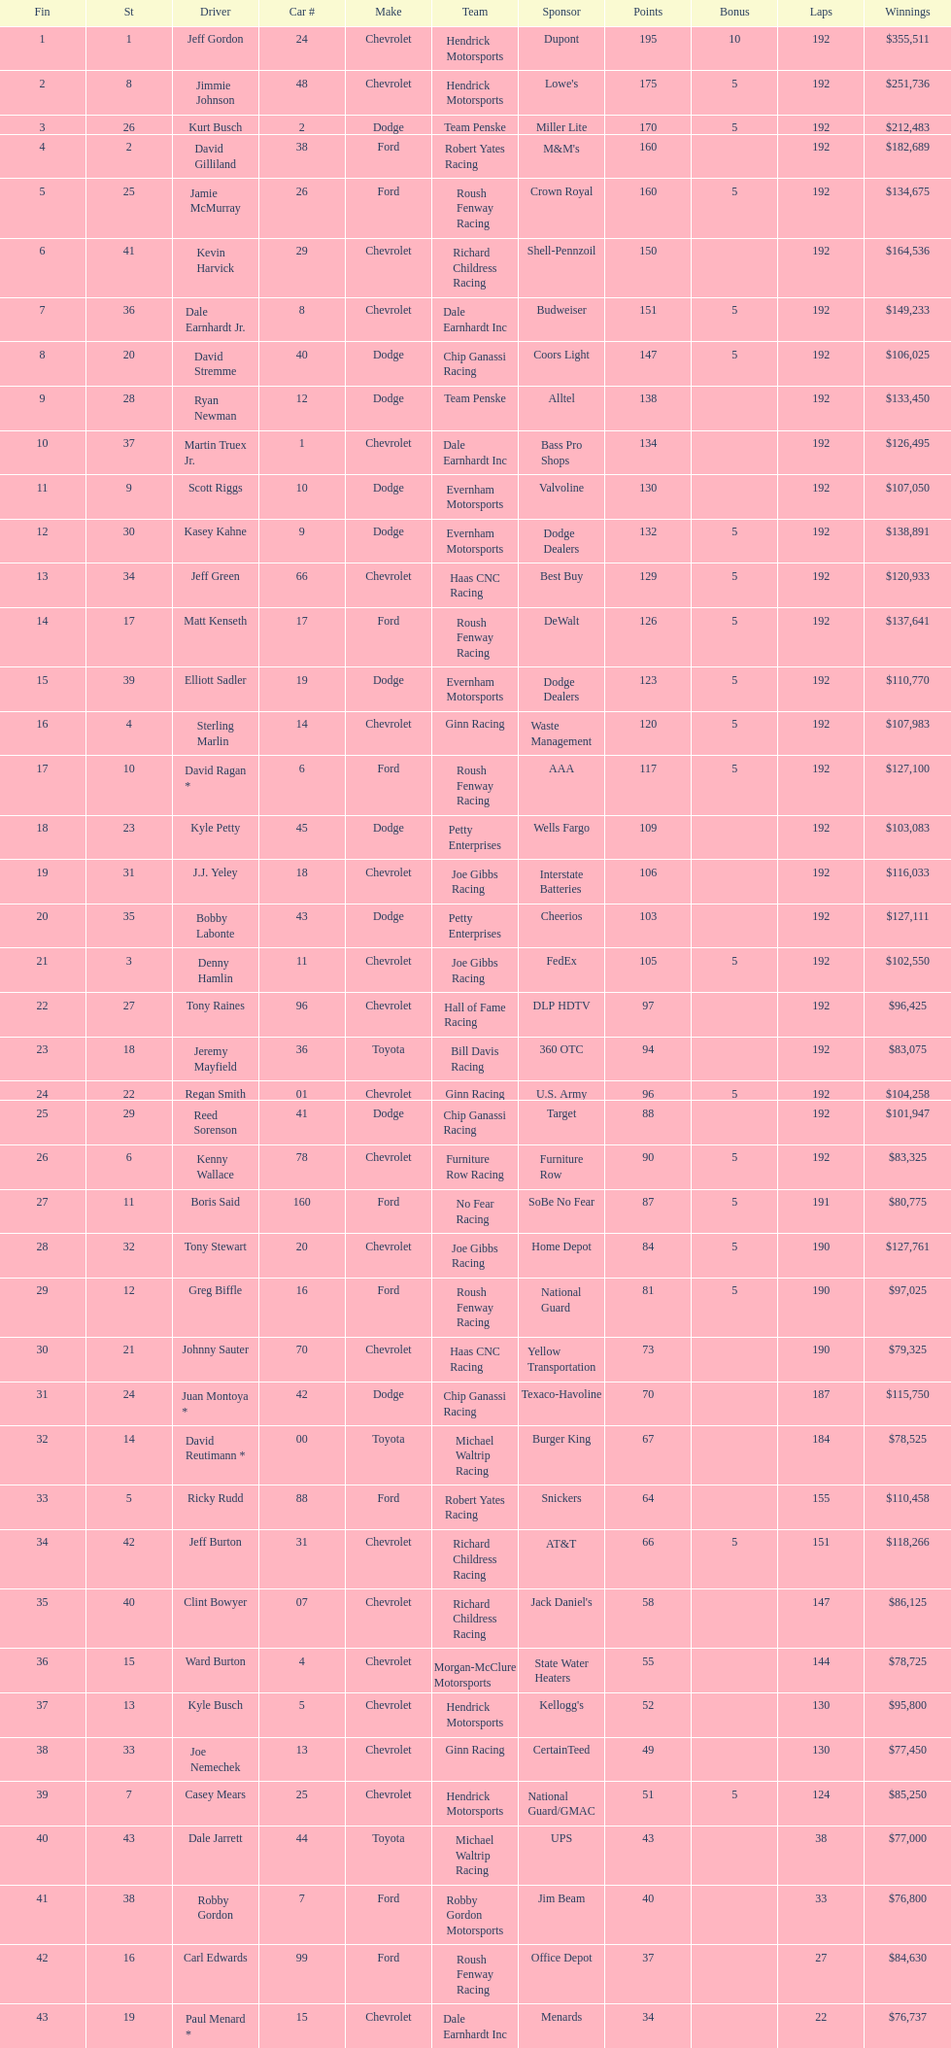What was jimmie johnson's winnings? $251,736. 